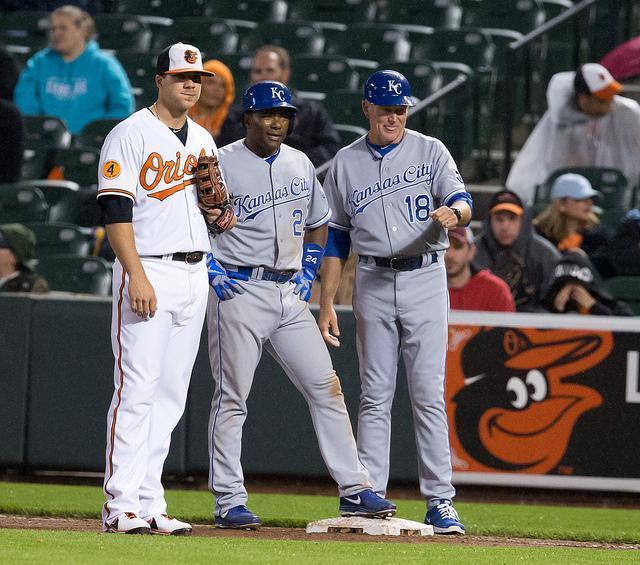How many people are in the picture?
Give a very brief answer. 11. How many chairs can be seen?
Give a very brief answer. 8. How many zebras are in the photo?
Give a very brief answer. 0. 